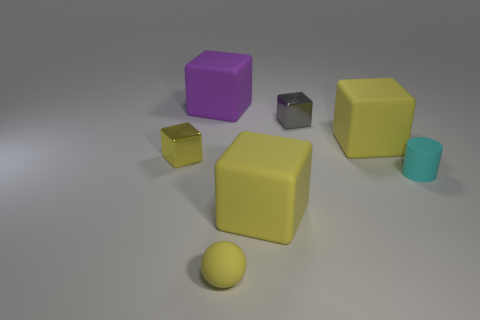Is there any other thing that has the same color as the sphere?
Ensure brevity in your answer.  Yes. There is another small thing that is the same shape as the small gray metal thing; what is its material?
Provide a succinct answer. Metal. The small thing that is both behind the cyan rubber cylinder and on the right side of the purple rubber cube is made of what material?
Offer a very short reply. Metal. What number of large things are the same shape as the tiny yellow metallic object?
Give a very brief answer. 3. There is a rubber object that is right of the large yellow block that is behind the cyan matte thing; what color is it?
Offer a terse response. Cyan. Are there the same number of yellow spheres that are in front of the rubber ball and cyan rubber cylinders?
Provide a short and direct response. No. Are there any green things that have the same size as the cyan matte object?
Keep it short and to the point. No. Is the size of the matte sphere the same as the metallic object left of the gray metallic object?
Make the answer very short. Yes. Are there an equal number of metal cubes that are in front of the cyan thing and yellow objects on the right side of the large purple thing?
Make the answer very short. No. There is a shiny thing that is the same color as the small ball; what shape is it?
Your response must be concise. Cube. 